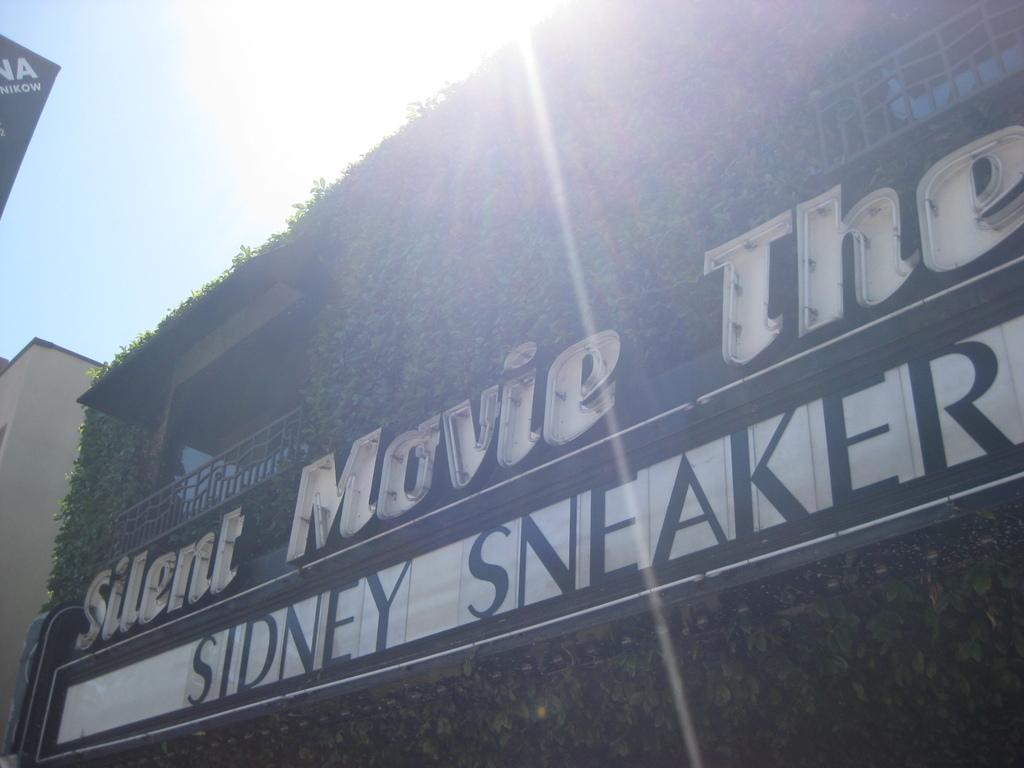<image>
Offer a succinct explanation of the picture presented. a sign for the silent movie theater featuring sidney sneaker 